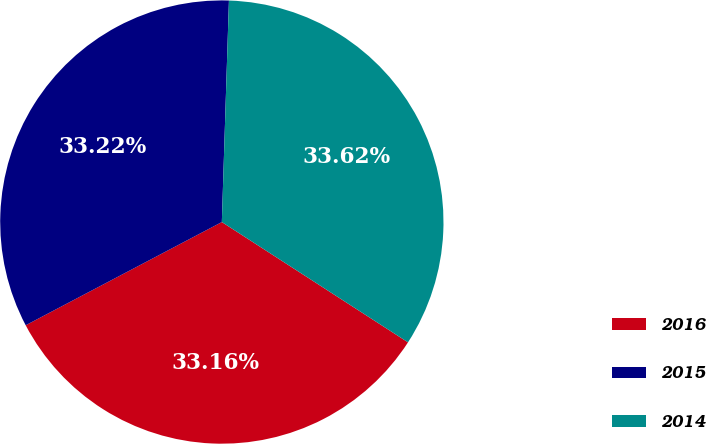Convert chart. <chart><loc_0><loc_0><loc_500><loc_500><pie_chart><fcel>2016<fcel>2015<fcel>2014<nl><fcel>33.16%<fcel>33.22%<fcel>33.62%<nl></chart> 